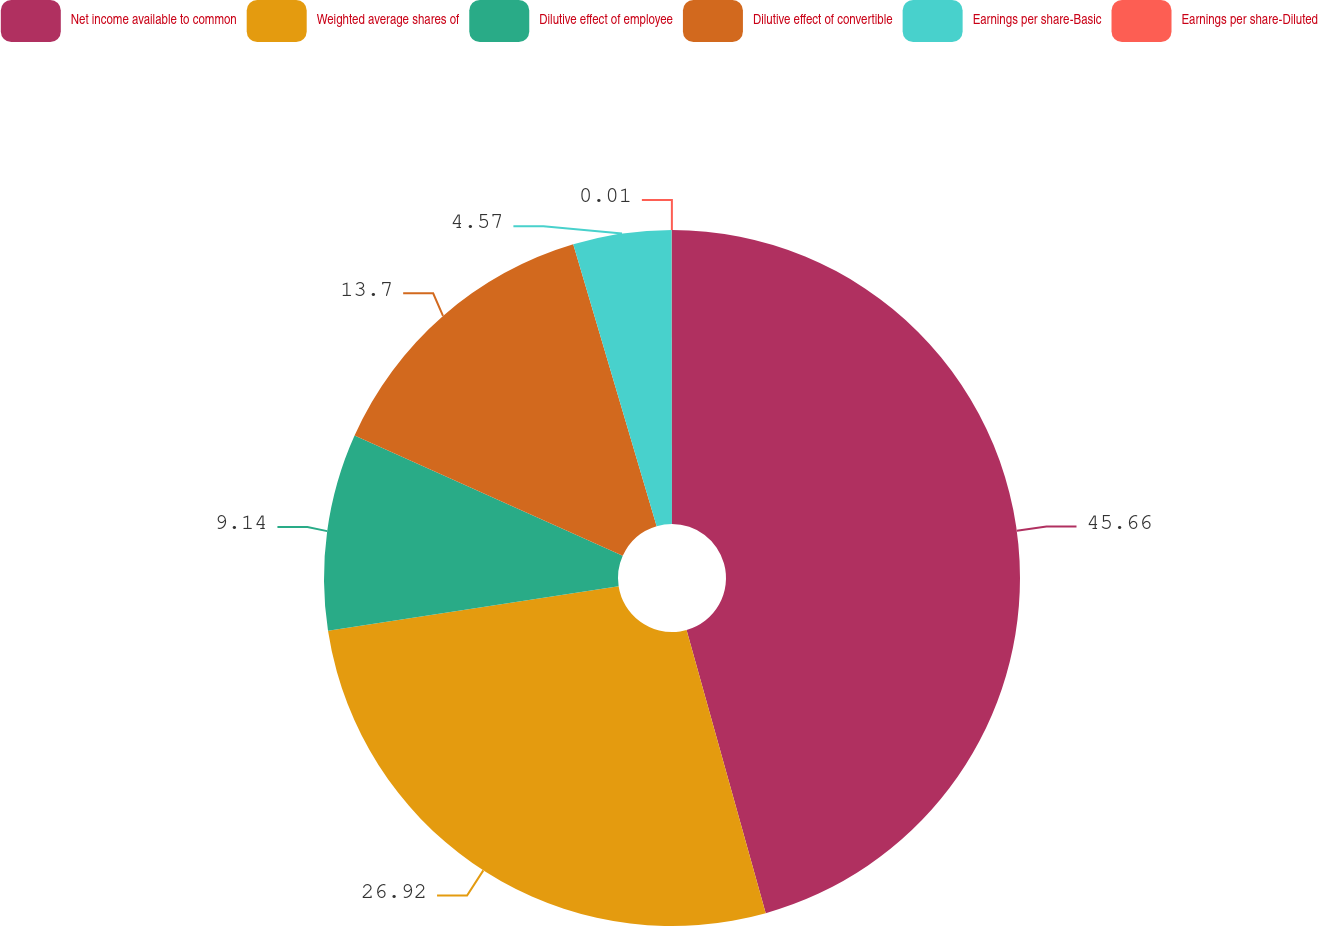Convert chart to OTSL. <chart><loc_0><loc_0><loc_500><loc_500><pie_chart><fcel>Net income available to common<fcel>Weighted average shares of<fcel>Dilutive effect of employee<fcel>Dilutive effect of convertible<fcel>Earnings per share-Basic<fcel>Earnings per share-Diluted<nl><fcel>45.66%<fcel>26.92%<fcel>9.14%<fcel>13.7%<fcel>4.57%<fcel>0.01%<nl></chart> 